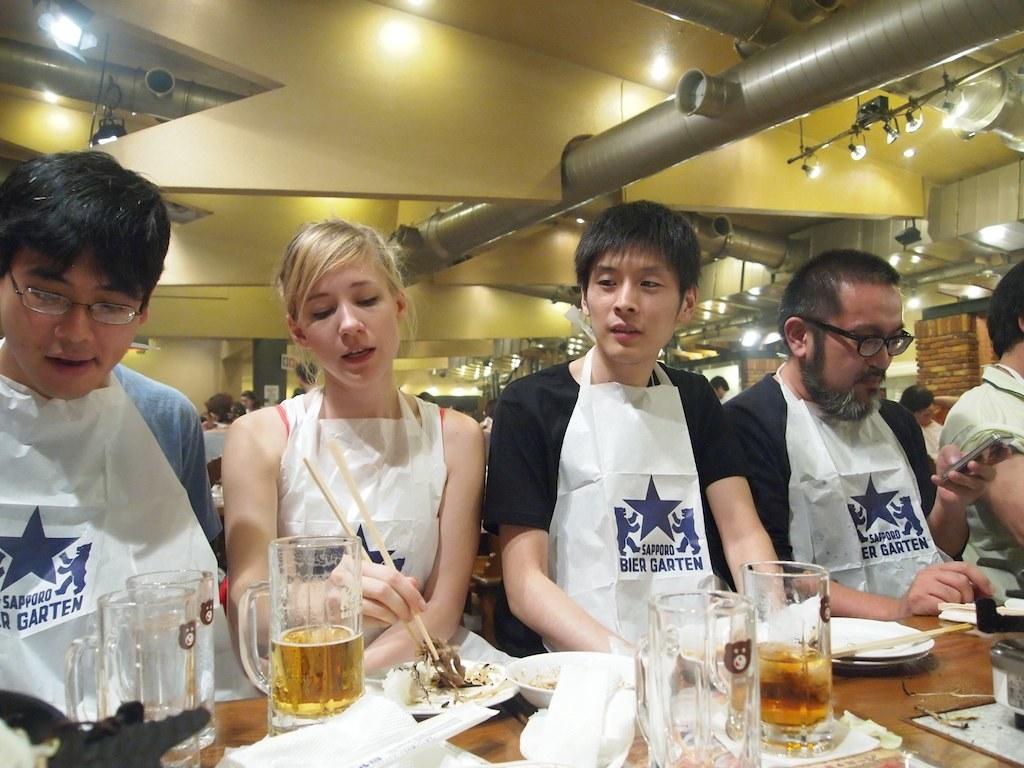Describe this image in one or two sentences. In this image I can see five persons are sitting on the chairs in front of a table on which I can see glasses, plates, sticks and so on. In the background I can see a group of people, tables, wall, AC ducts, lights and metal rods. This image is taken may be in a restaurant. 